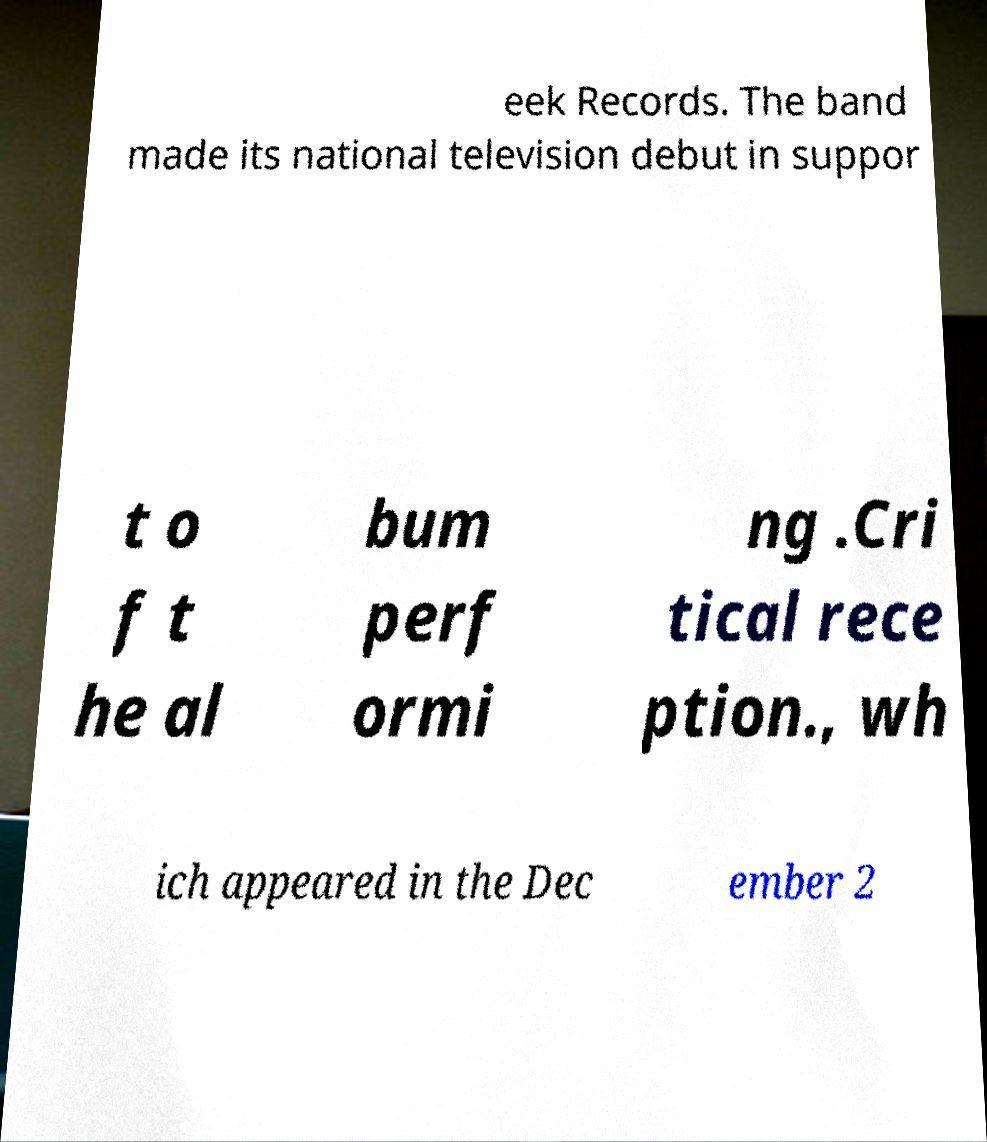Could you extract and type out the text from this image? eek Records. The band made its national television debut in suppor t o f t he al bum perf ormi ng .Cri tical rece ption., wh ich appeared in the Dec ember 2 